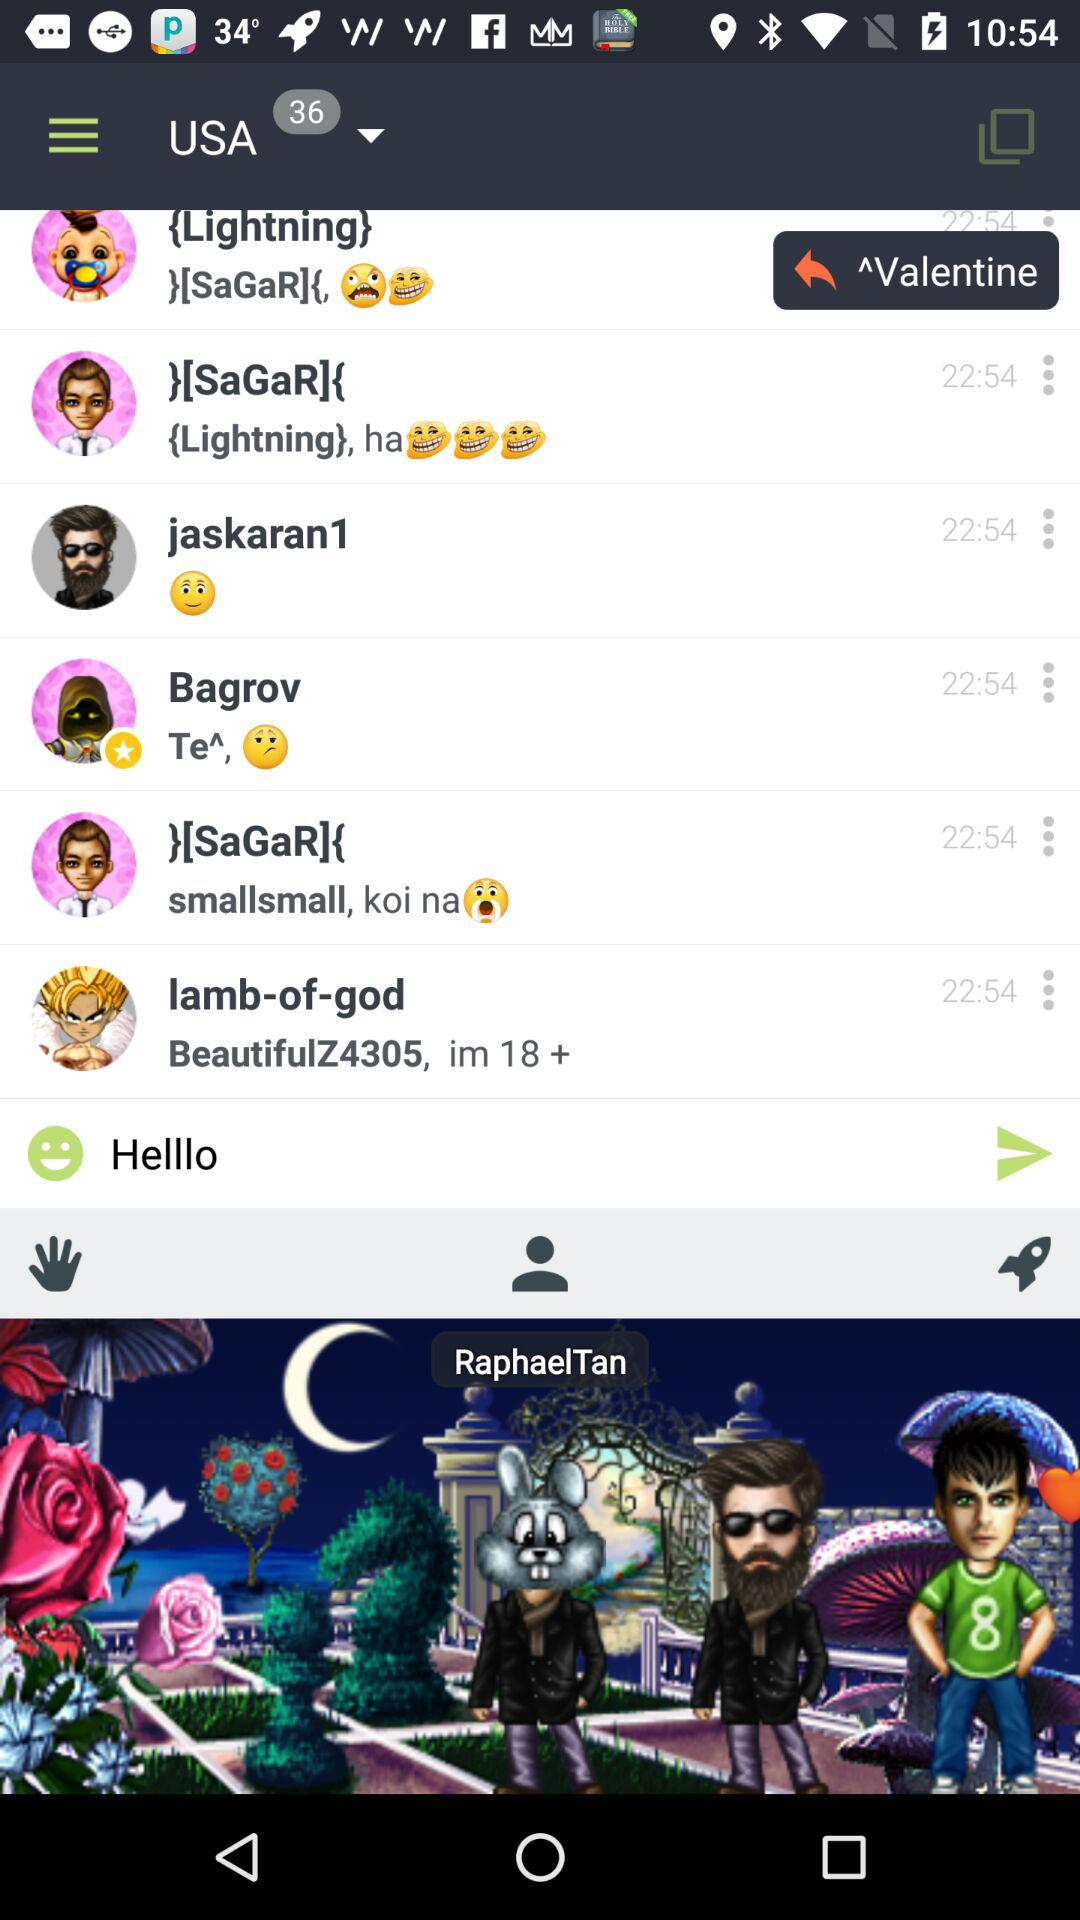How many unread messages are there in the USA group? There are 36 unread messages. 